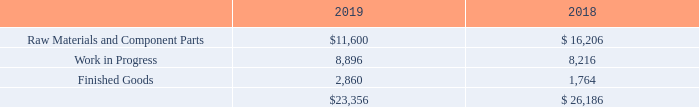6. Inventories
Inventories at April 30, 2019 and 2018, respectively, consisted of the following (in thousands):
For the year ended April 30, 2018, the Company recorded a non-cash write-down of approximately $5.6 million of inventory. Inventory write-down resulted from two principal factors: (1) adoption by satellite manufacturers of policies precluding the use of parts and components over ten years old. This policy was unanticipated and resulted in reduced likelihood of FEI being able to use inventory that exceeds that threshold, and (2) changing technology associated with the advanced analog-to-digital converters which enables direct synthesis of certain frequencies for which FEI previously provided frequency conversion technology, reducing the likelihood that some parts and components associated with frequency conversion will be usable. Additionally, the Company’s new inventory reserve policy resulted in a charge of $1.1 million in the fiscal year ended April 30, 2019. Inventory reserves included in inventory were $6.6 million and $5.5 million for the fiscal years ended April 30, 2019 and 2018, respectively.
What is the amount of raw materials and component parts in 2019 and 2018 respectively?
Answer scale should be: thousand. $11,600, $ 16,206. What is the amount of work in progress inventory in 2019 and 2018 respectively?
Answer scale should be: thousand. 8,896, 8,216. What is the amount of finished goods in 2019 and 2018 respectively?
Answer scale should be: thousand. 2,860, 1,764. What is the average amount of raw materials and component parts in 2018 and 2019?
Answer scale should be: thousand. (11,600+16,206)/2
Answer: 13903. In 2019, what is the percentage constitution of finished goods among the total inventory amount?
Answer scale should be: percent. 2,860/23,356
Answer: 12.25. What is the percentage change of amount of inventory from 2018 and 2019 ?
Answer scale should be: percent. (23,356-26,186)/26,186
Answer: -10.81. 